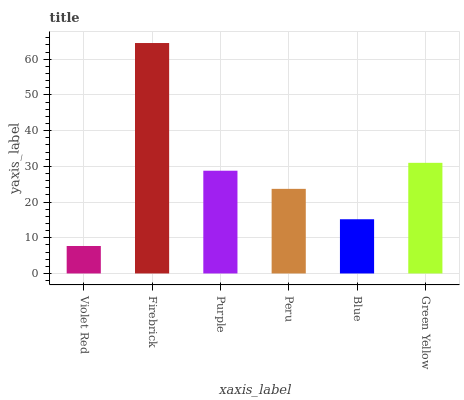Is Violet Red the minimum?
Answer yes or no. Yes. Is Firebrick the maximum?
Answer yes or no. Yes. Is Purple the minimum?
Answer yes or no. No. Is Purple the maximum?
Answer yes or no. No. Is Firebrick greater than Purple?
Answer yes or no. Yes. Is Purple less than Firebrick?
Answer yes or no. Yes. Is Purple greater than Firebrick?
Answer yes or no. No. Is Firebrick less than Purple?
Answer yes or no. No. Is Purple the high median?
Answer yes or no. Yes. Is Peru the low median?
Answer yes or no. Yes. Is Peru the high median?
Answer yes or no. No. Is Firebrick the low median?
Answer yes or no. No. 